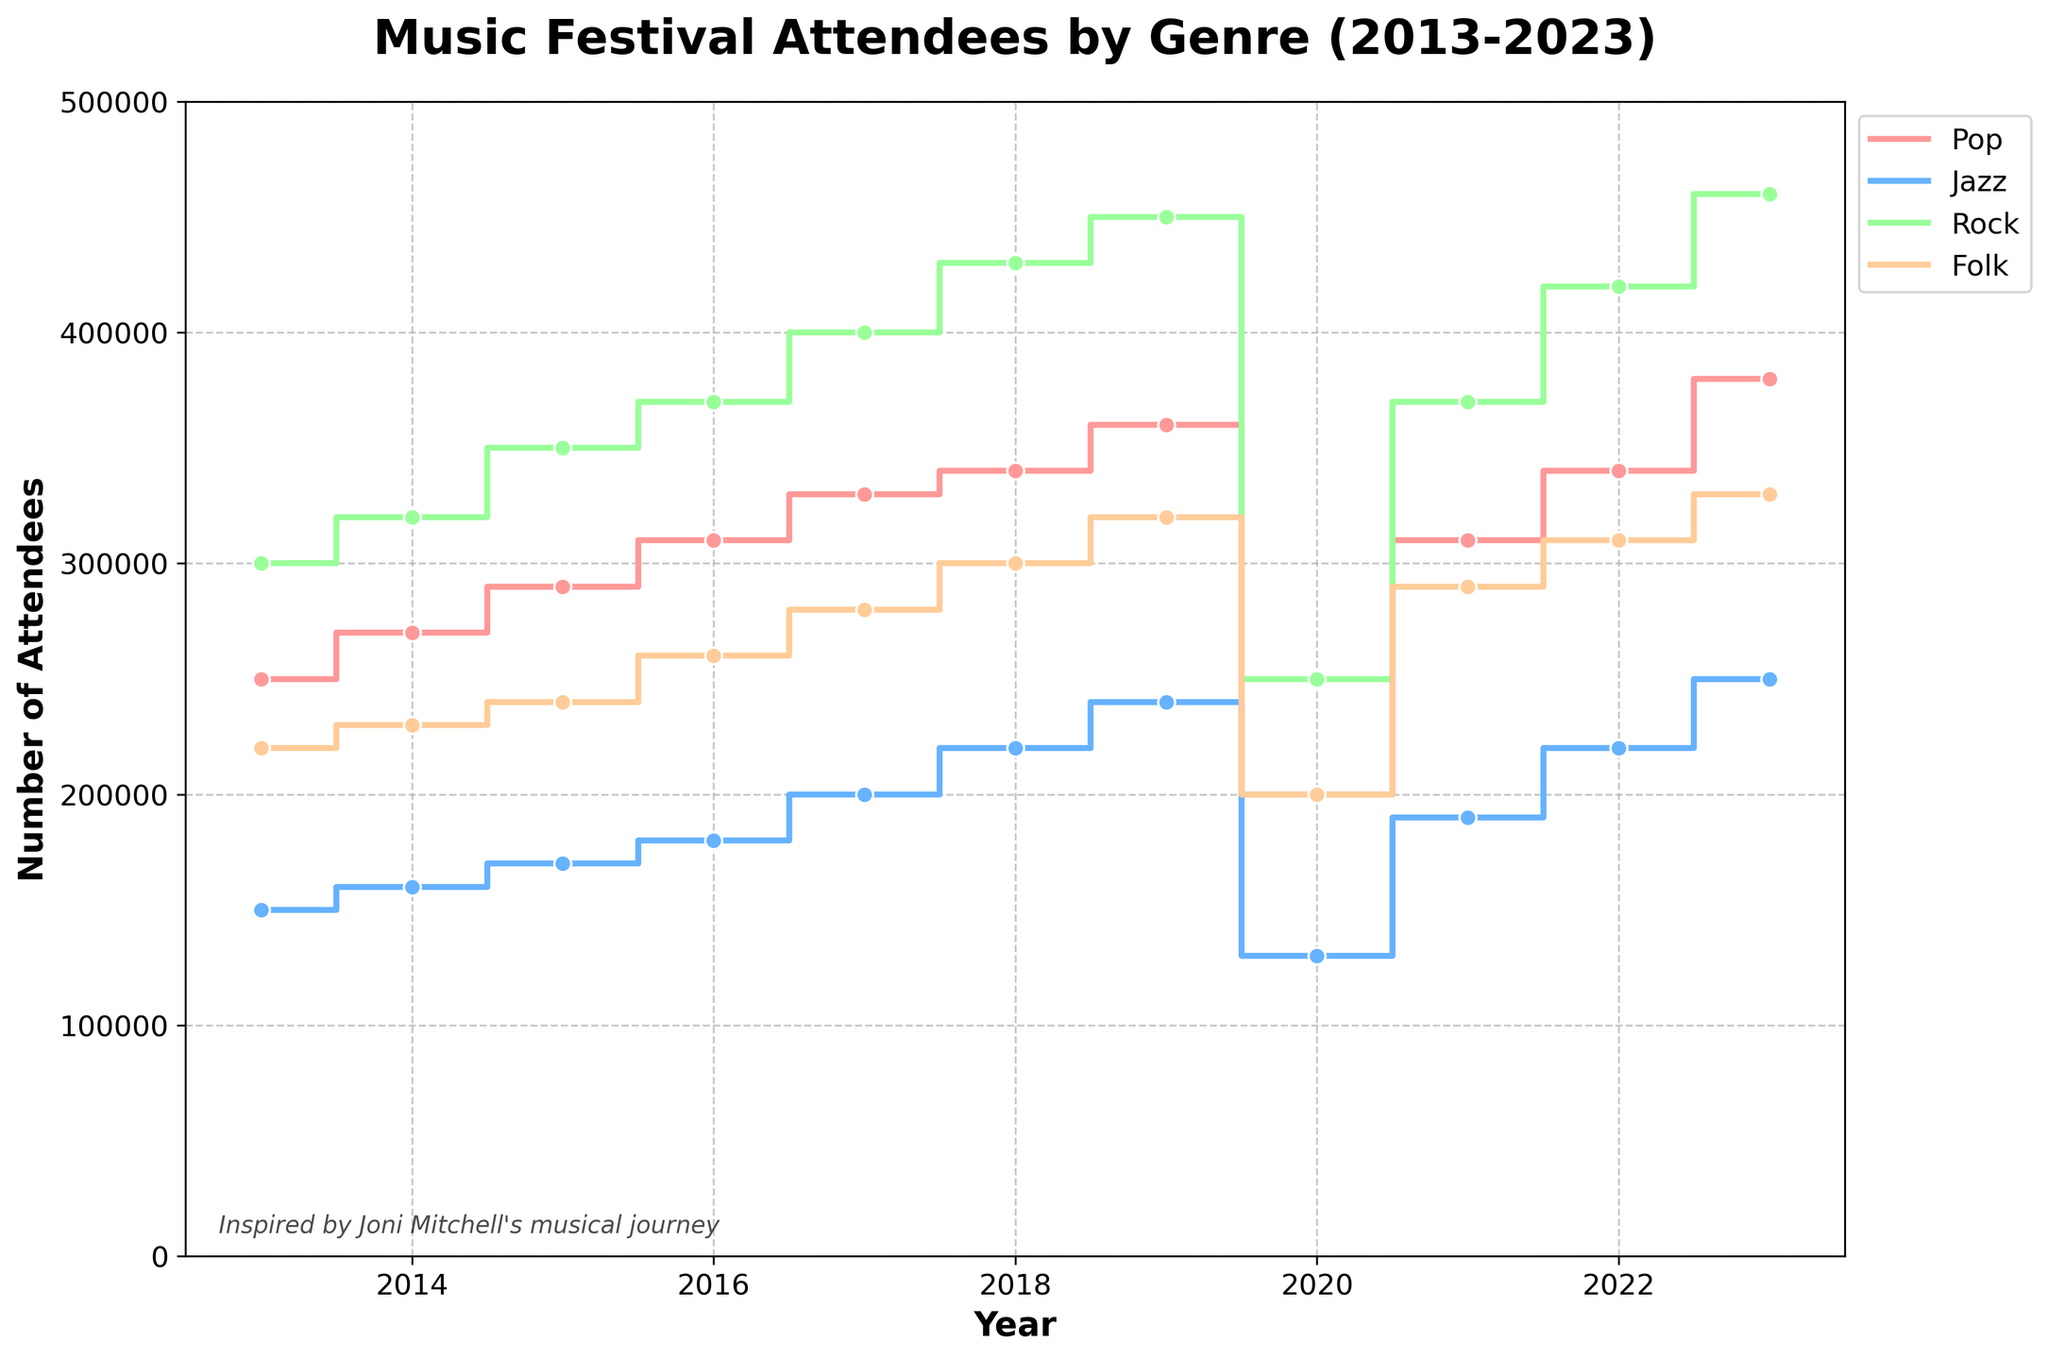what is the title of the plot? The title of the plot is usually found at the top of the graph. In this case, the plot's title reads, "Music Festival Attendees by Genre (2013-2023)".
Answer: Music Festival Attendees by Genre (2013-2023) How many genres are displayed in the plot? By observing the distinct colors and labels in the legend, we can see there are four genres: Pop, Jazz, Rock, and Folk.
Answer: Four Which year had the lowest number of attendees for Folk Festivals? We look for the lowest point on the Folk Festival line (represented by one of the colors and indicated in the legend). The lowest number of attendees for Folk Festivals occurred in the year 2020.
Answer: 2020 Compare the number of attendees for Rock and Jazz Festivals in 2017. By checking the points on the Rock and Jazz lines for the year 2017, we see that Rock had 400,000 attendees, and Jazz had 200,000 attendees. So, Rock had twice as many attendees as Jazz in 2017.
Answer: Rock had twice as many attendees as Jazz What is the trend of the number of attendees for Pop Festivals from 2013 to 2023? Examining the step plot for Pop Festivals, we see a general upward trend from 2013 to 2023, indicating increasing attendance numbers every year, except for a decline in 2020.
Answer: Increasing trend with a drop in 2020 Which genre experienced the highest growth in attendees between 2020 and 2023? By comparing the starting and ending values for each genre between these years, we see the largest growth in Rock Festival attendees, from 250,000 in 2020 to 460,000 in 2023, an increase of 210,000.
Answer: Rock How did the number of music festivals change from 2020 to 2021? Looking at the number of Music Festivals for these years, we see an increase from 150 in 2020 to 190 in 2021.
Answer: Increased by 40 What is the average number of attendees for Jazz Festivals between 2013 and 2015? Adding up the attendees for Jazz Festivals in 2013, 2014, and 2015 gives us 150,000 + 160,000 + 170,000 = 480,000. Dividing this sum by 3, we get 480,000 / 3 = 160,000 attendees on average.
Answer: 160,000 In which year did Pop Festivals surpass 300,000 attendees for the first time? Checking the Pop Festival attendees plot line, we see that the number first exceeds 300,000 in the year 2017.
Answer: 2017 